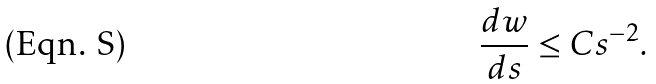<formula> <loc_0><loc_0><loc_500><loc_500>\frac { d w } { d s } \leq C s ^ { - 2 } .</formula> 